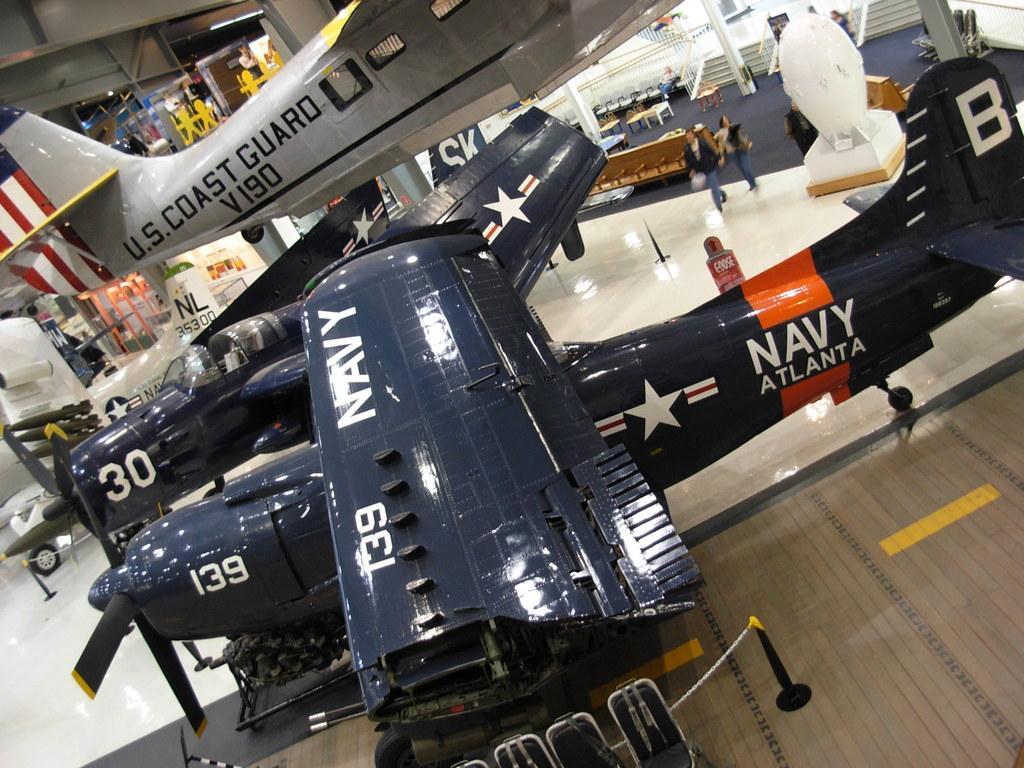Could you give a brief overview of what you see in this image? This image is taken indoors. In the background there are a few walls. There are many pillars. There are a few stairs. There are many empty chairs and tables. There is a railing and there are a few objects. In the middle of the image there are a few airplanes and a man and a woman are walking on the floor. There is a text on the airplanes. At the bottom of the image there is a floor and there is a fence. 